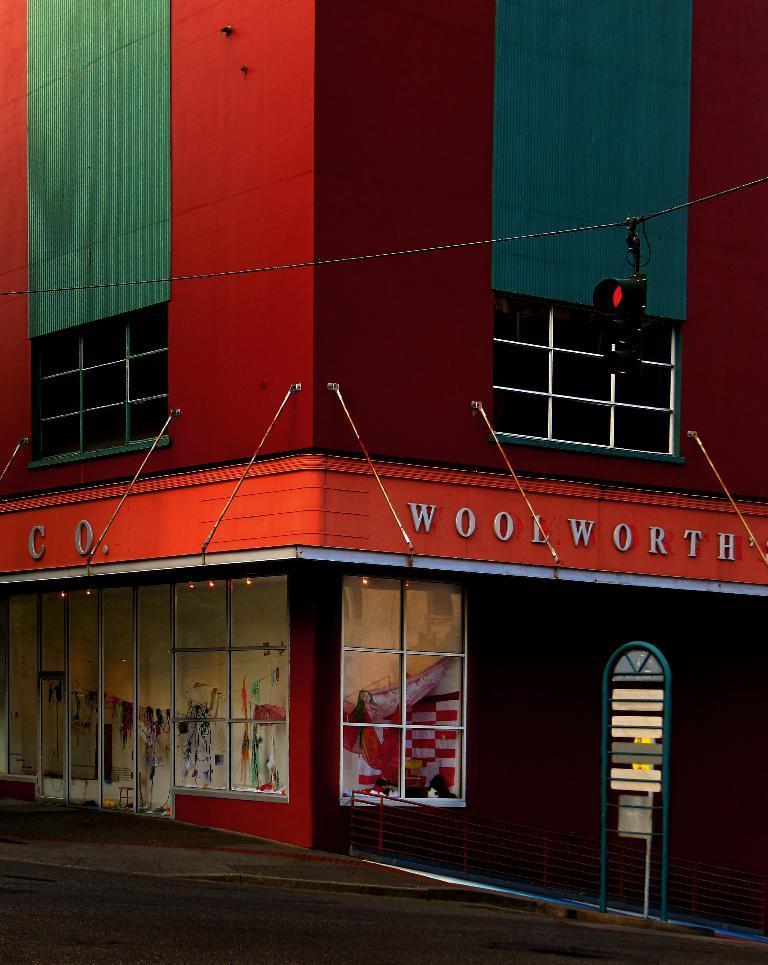Please provide a concise description of this image. In this image I can see a red colour building, few boards, number of clothes, a wire, a signal light and here I can see something is written. 